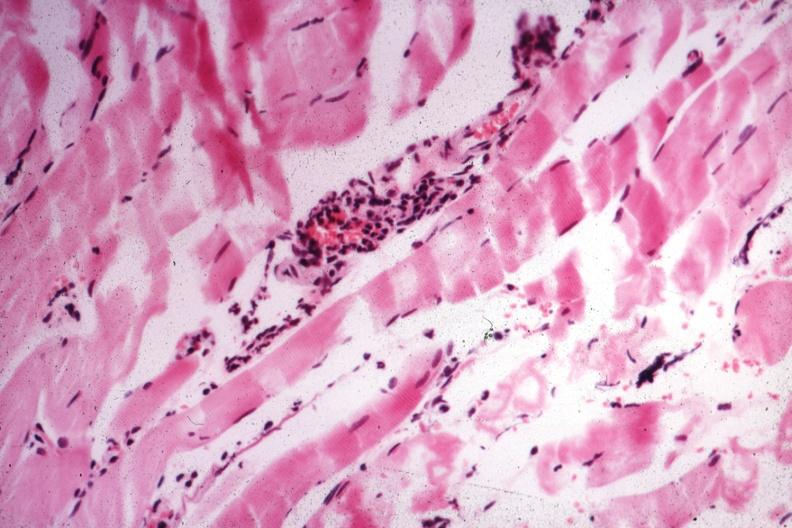what is present?
Answer the question using a single word or phrase. Soft tissue 